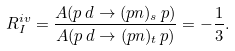<formula> <loc_0><loc_0><loc_500><loc_500>R _ { I } ^ { i v } = \frac { A ( p \, d \to ( p n ) _ { s } \, p ) } { A ( p \, d \to ( p n ) _ { t } \, p ) } = - \frac { 1 } { 3 } .</formula> 